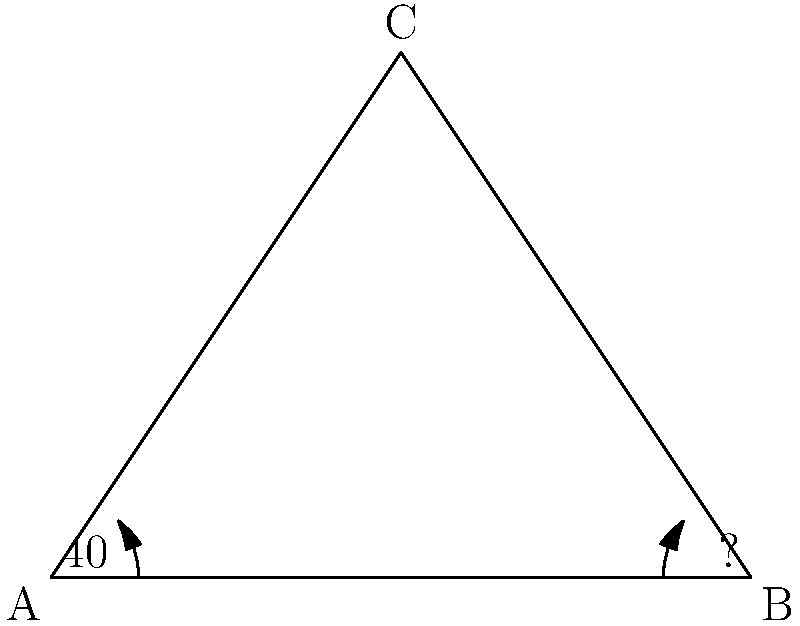In the triangle ABC shown above, angle A measures $40°$. What is the measure of angle B? Note that the diagram is not drawn to scale, and the side lengths are not provided. To solve this problem, we need to apply the principle that the sum of angles in a triangle is always $180°$. However, we are only given one angle measure, which is insufficient to determine the measure of angle B directly. Let's break down the problem:

1. Let $x$ be the measure of angle B and $y$ be the measure of angle C.

2. We know that in any triangle: $\angle A + \angle B + \angle C = 180°$

3. Substituting the known values:
   $40° + x + y = 180°$

4. We have one equation with two unknowns, which means we cannot solve for $x$ (angle B) without additional information.

5. To find angle B, we would need either:
   - The measure of angle C, or
   - The lengths of at least two sides of the triangle

Without this additional information, it's impossible to determine the exact measure of angle B.
Answer: Insufficient information to determine angle B 